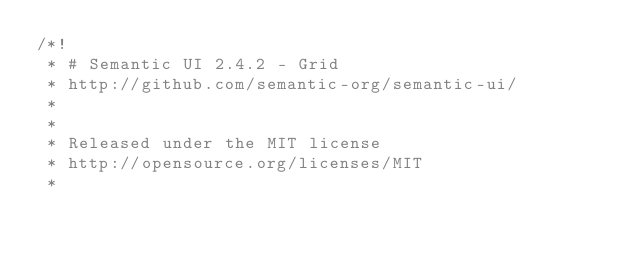<code> <loc_0><loc_0><loc_500><loc_500><_CSS_>/*!
 * # Semantic UI 2.4.2 - Grid
 * http://github.com/semantic-org/semantic-ui/
 *
 *
 * Released under the MIT license
 * http://opensource.org/licenses/MIT
 *</code> 